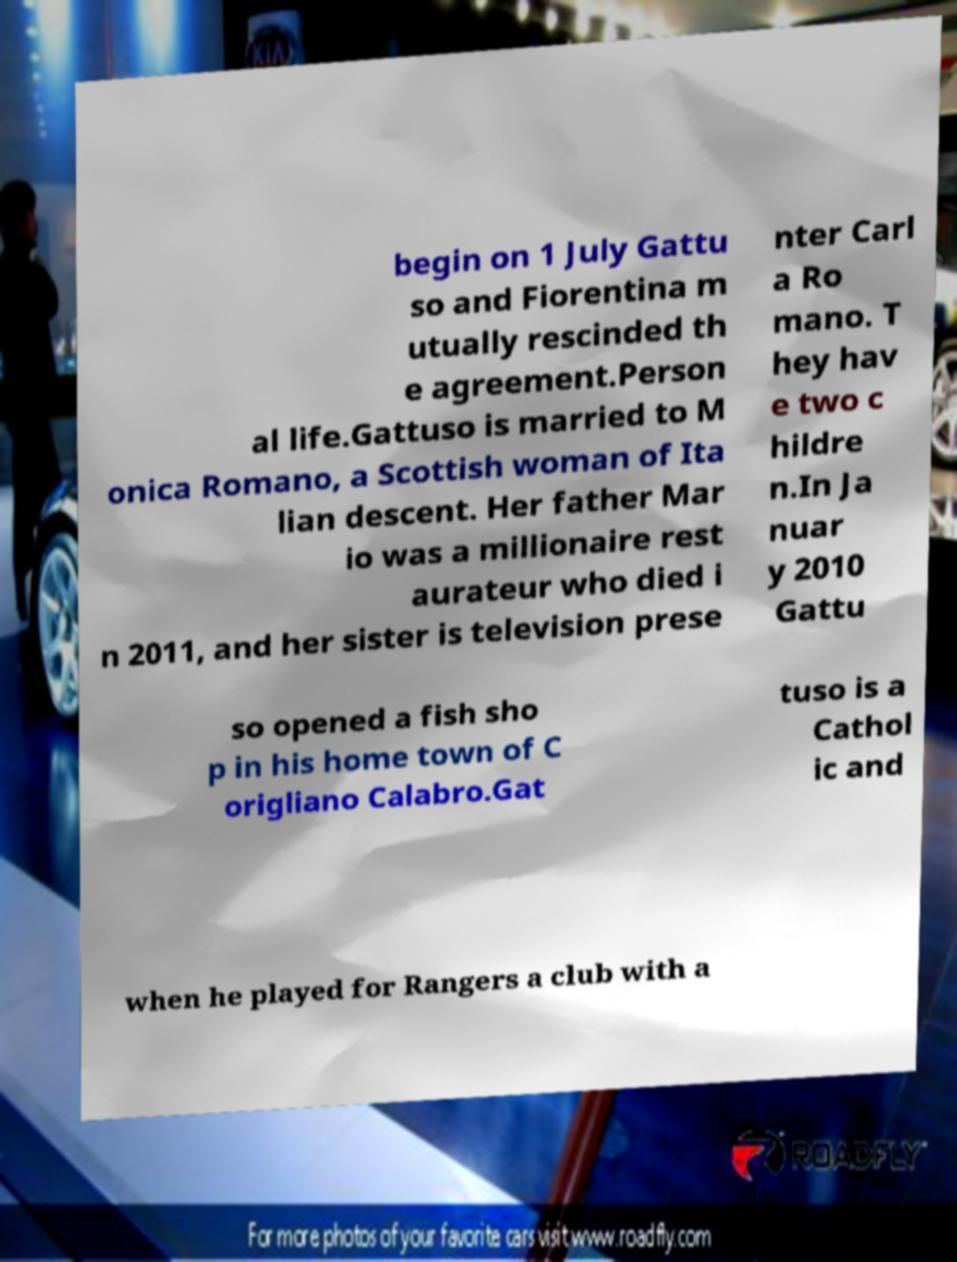Can you accurately transcribe the text from the provided image for me? begin on 1 July Gattu so and Fiorentina m utually rescinded th e agreement.Person al life.Gattuso is married to M onica Romano, a Scottish woman of Ita lian descent. Her father Mar io was a millionaire rest aurateur who died i n 2011, and her sister is television prese nter Carl a Ro mano. T hey hav e two c hildre n.In Ja nuar y 2010 Gattu so opened a fish sho p in his home town of C origliano Calabro.Gat tuso is a Cathol ic and when he played for Rangers a club with a 